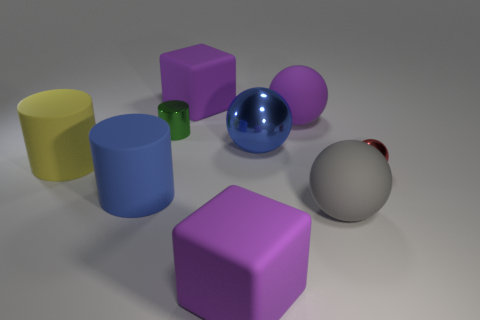Subtract 1 balls. How many balls are left? 3 Add 1 purple matte balls. How many objects exist? 10 Subtract all cylinders. How many objects are left? 6 Add 7 blue matte objects. How many blue matte objects are left? 8 Add 6 blue matte objects. How many blue matte objects exist? 7 Subtract 1 gray spheres. How many objects are left? 8 Subtract all big matte balls. Subtract all red objects. How many objects are left? 6 